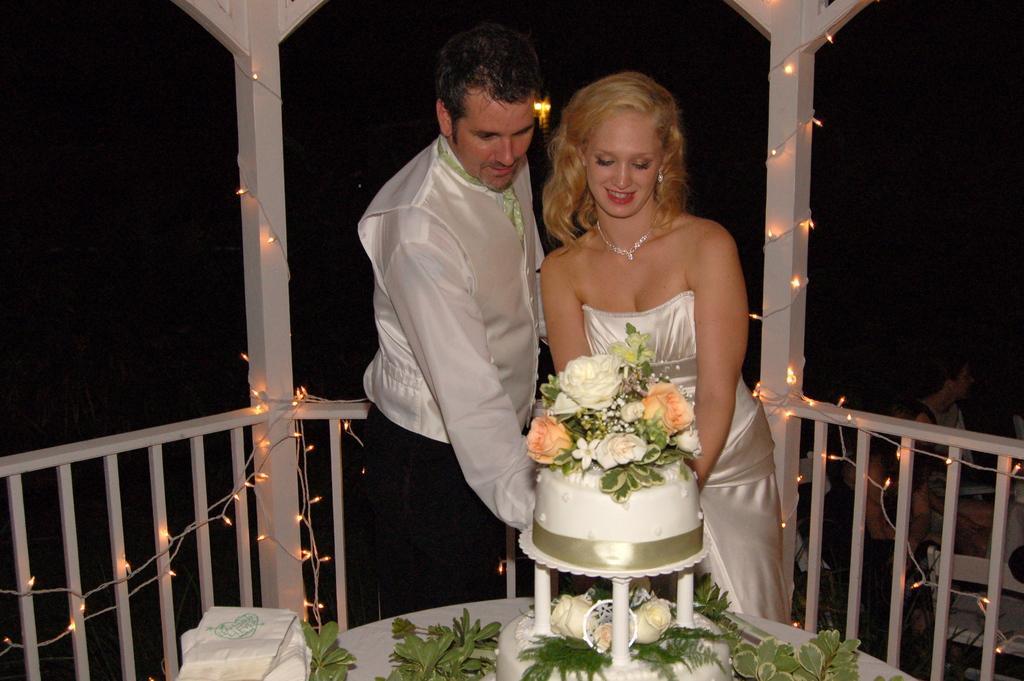Please provide a concise description of this image. In this image we can see two persons. In front of the persons we can see the leaves and a cake on the table. Behind the persons we can see a wooden fencing and poles. On the fencing and poles we can see the lights. In the bottom right, there are few persons. The background of the image is dark. 